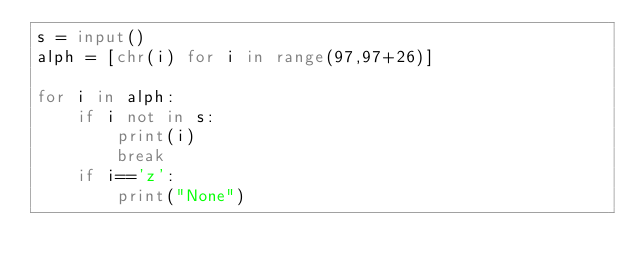Convert code to text. <code><loc_0><loc_0><loc_500><loc_500><_Python_>s = input()
alph = [chr(i) for i in range(97,97+26)]

for i in alph:
    if i not in s:
        print(i)
        break
    if i=='z':
        print("None")
</code> 